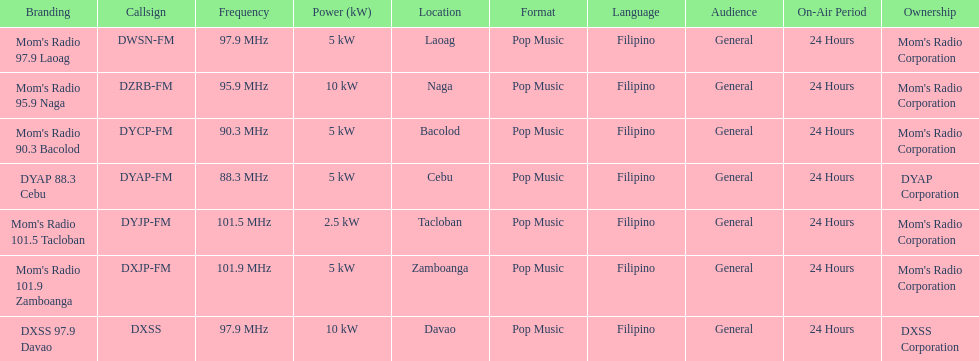Which of these stations broadcasts with the least power? Mom's Radio 101.5 Tacloban. 